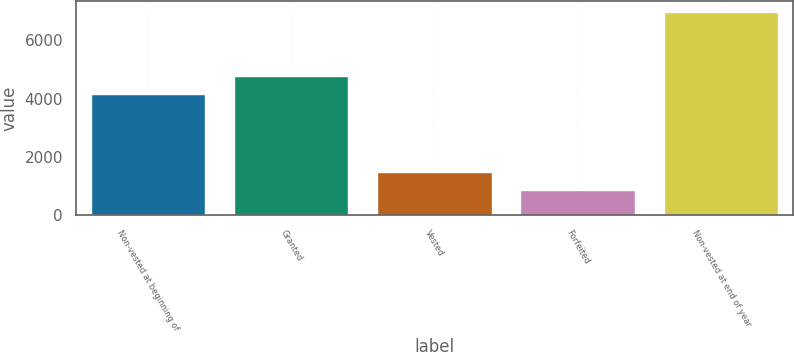Convert chart. <chart><loc_0><loc_0><loc_500><loc_500><bar_chart><fcel>Non-vested at beginning of<fcel>Granted<fcel>Vested<fcel>Forfeited<fcel>Non-vested at end of year<nl><fcel>4164<fcel>4774.7<fcel>1494.7<fcel>884<fcel>6991<nl></chart> 